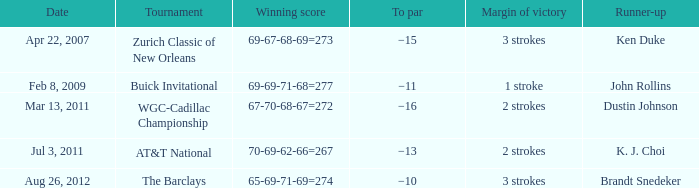What was the to par of the tournament that had Ken Duke as a runner-up? −15. 